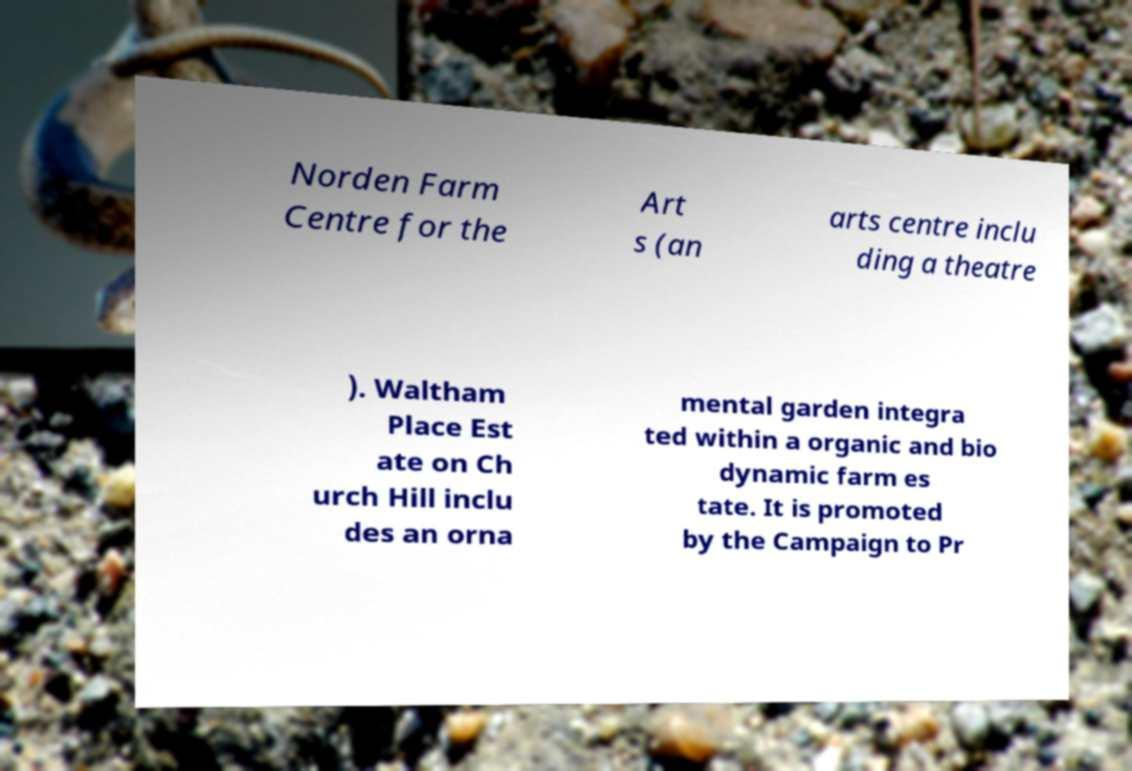Can you accurately transcribe the text from the provided image for me? Norden Farm Centre for the Art s (an arts centre inclu ding a theatre ). Waltham Place Est ate on Ch urch Hill inclu des an orna mental garden integra ted within a organic and bio dynamic farm es tate. It is promoted by the Campaign to Pr 